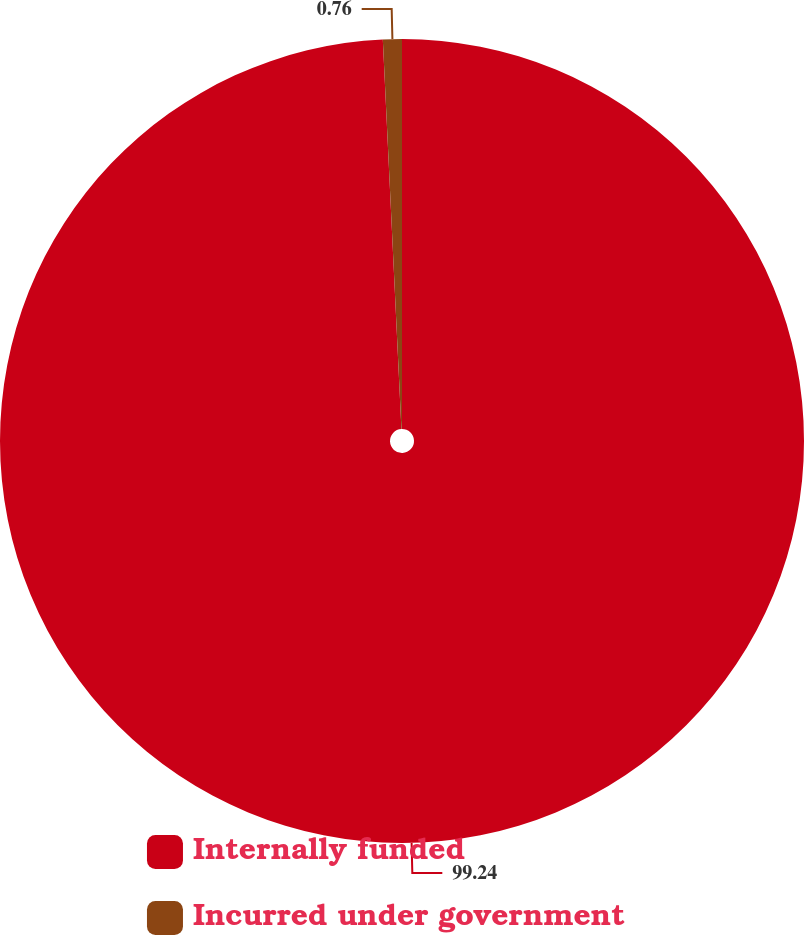<chart> <loc_0><loc_0><loc_500><loc_500><pie_chart><fcel>Internally funded<fcel>Incurred under government<nl><fcel>99.24%<fcel>0.76%<nl></chart> 